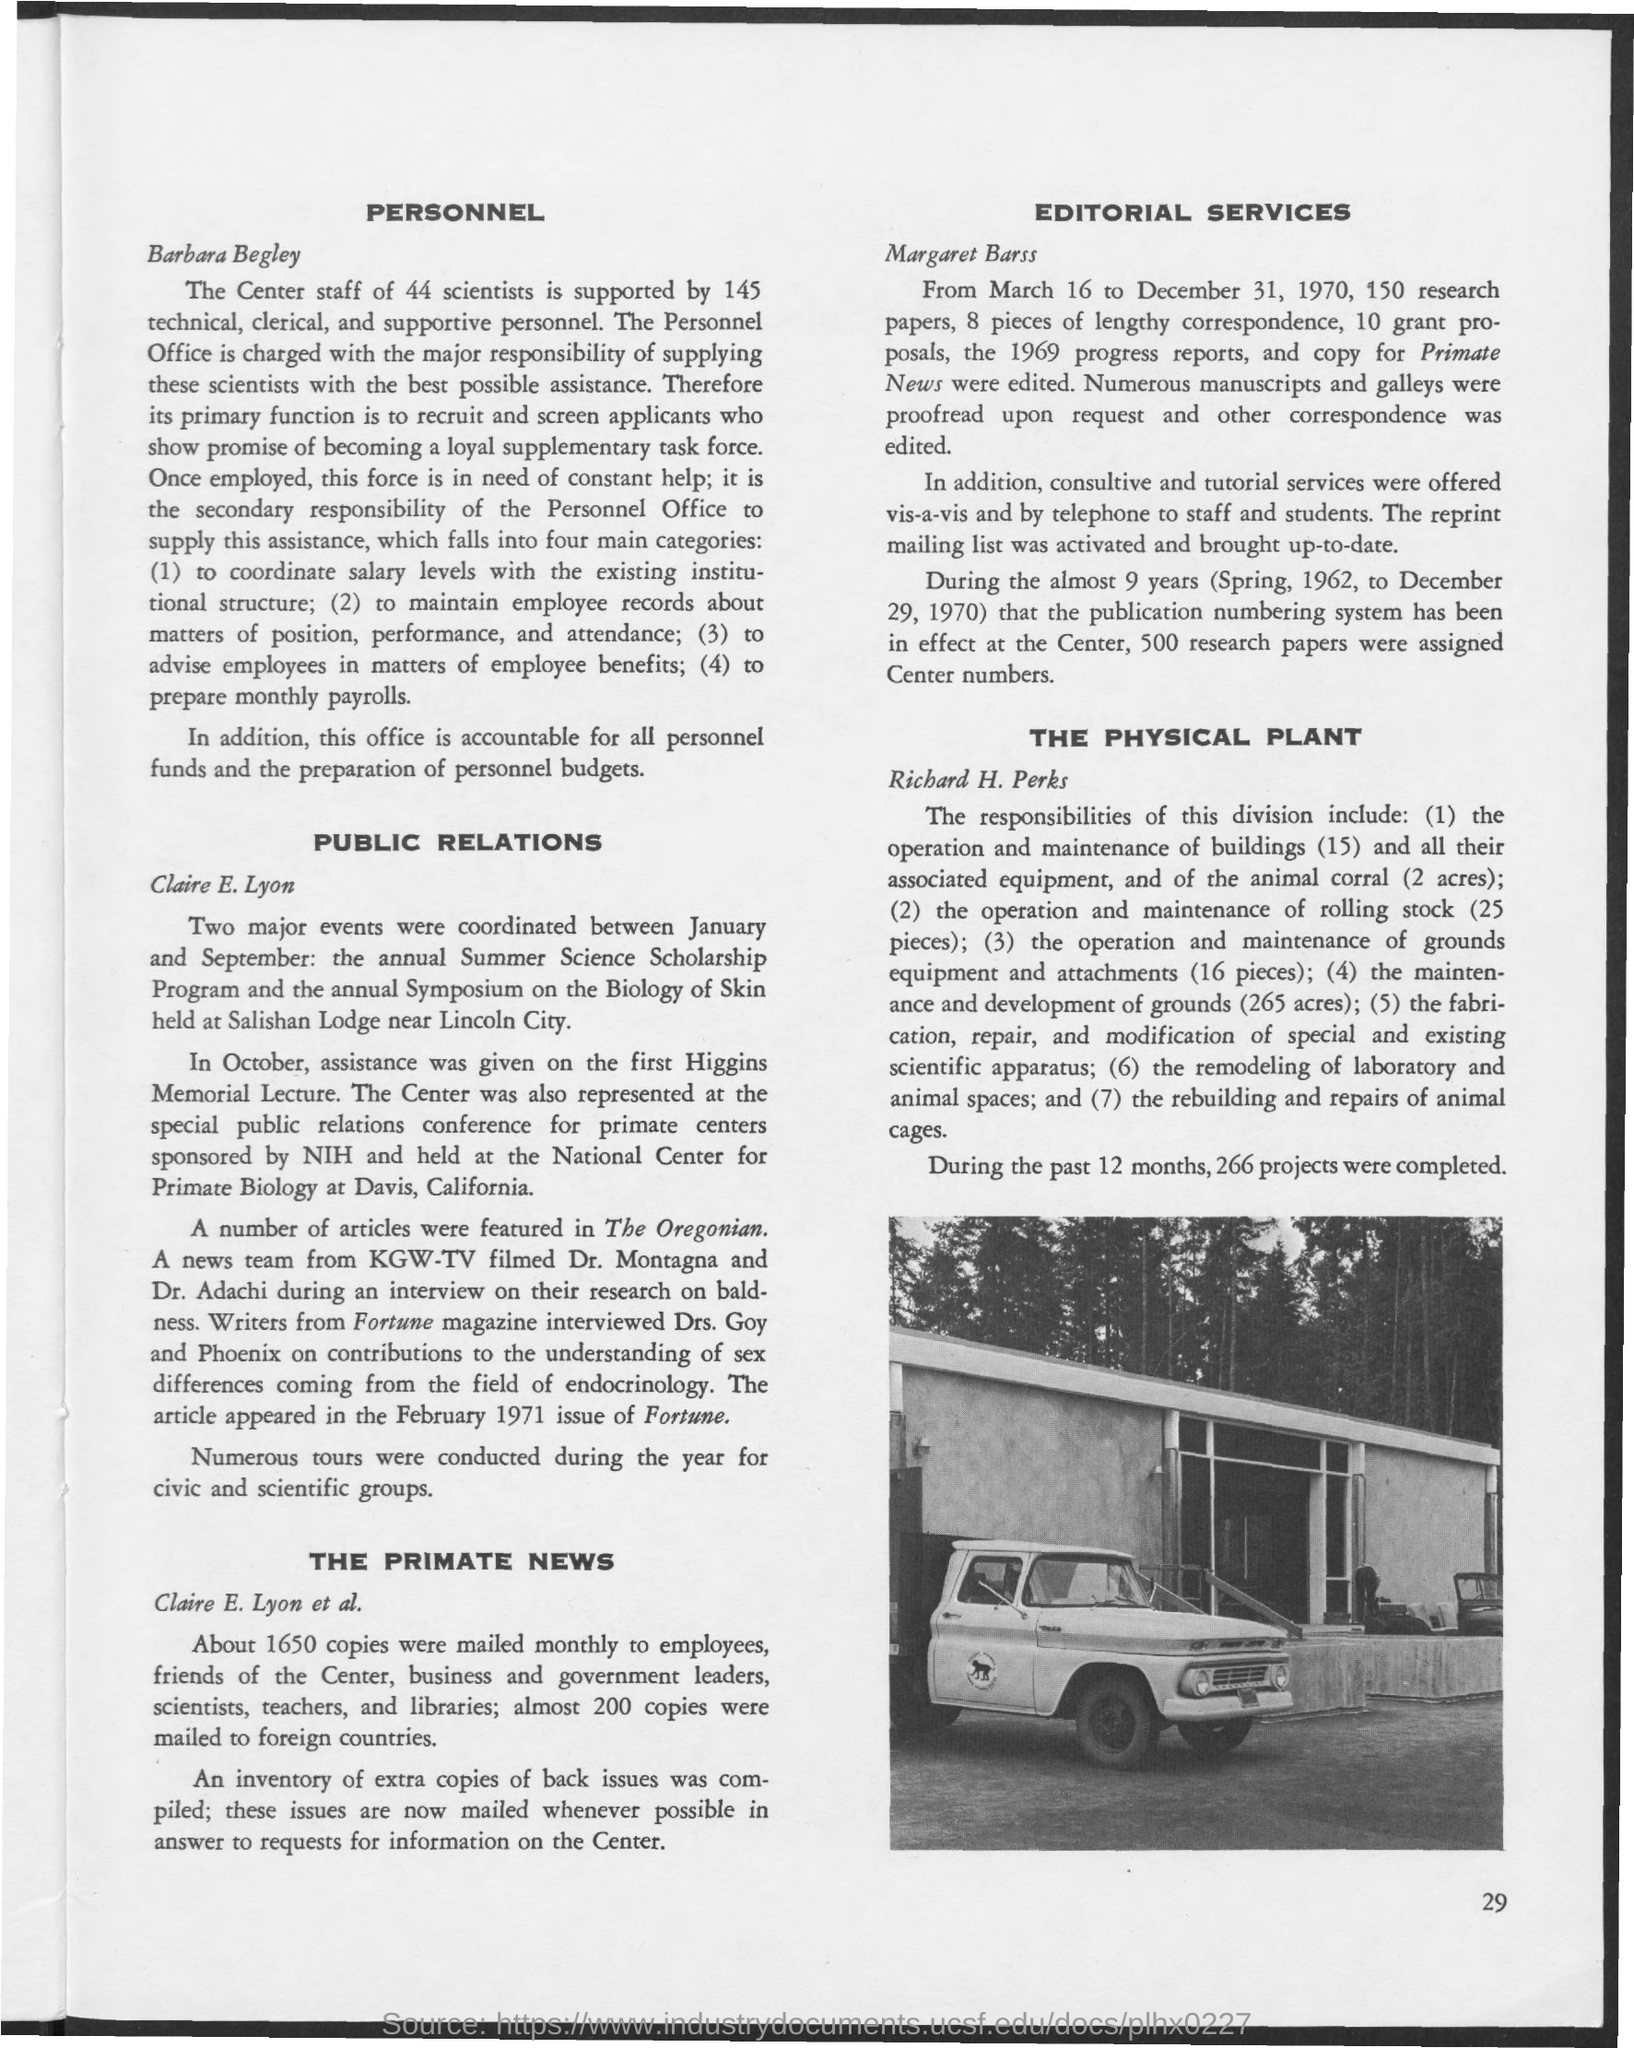Highlight a few significant elements in this photo. The page number located at the right bottom corner of the page is 29. Margaret Barss provides the service of 'EDITORIAL SERVICES.' During the period of March 16 to December 31, 1970, a total of 150 research papers were edited. I, [your name], hereby declare that writers from Fortune Magazine interviewed Drs. Goy and Phoenix. The Annual Symposium on the Biology of Skin is held at Salishan Lodge, which is located near Lincoln City. 